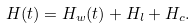<formula> <loc_0><loc_0><loc_500><loc_500>H ( t ) = H _ { w } ( t ) + H _ { l } + H _ { c } .</formula> 